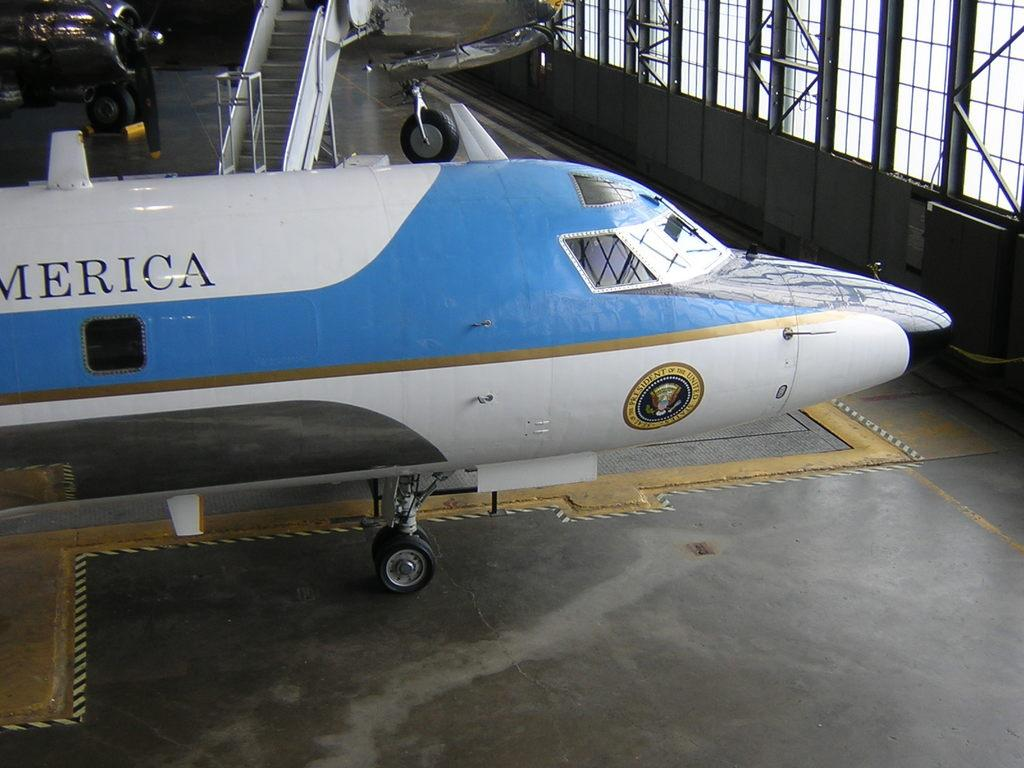<image>
Give a short and clear explanation of the subsequent image. The front half of a blue and white plane with the letters MERICA visible. 